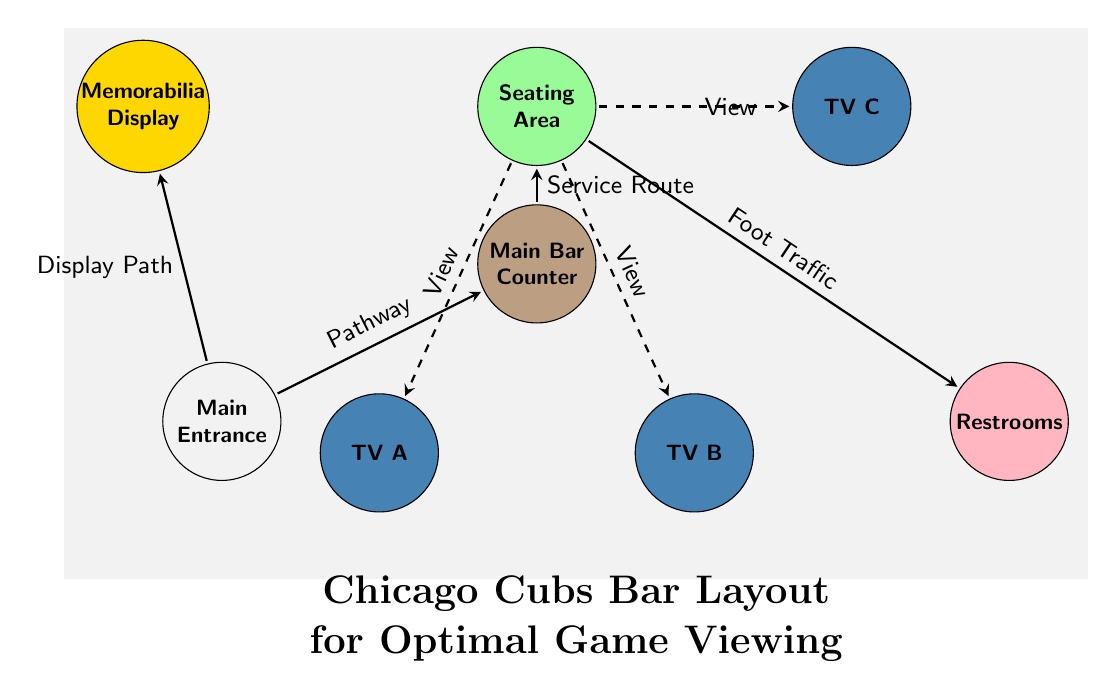What is the color of the main bar counter? The main bar counter is indicated in the diagram as a node filled with the color defined as "barcolor," which is RGB (188,158,130).
Answer: barcolor How many TVs are in the layout? The diagram shows three TVs labeled as TV A, TV B, and TV C. Counting these nodes reveals a total of three TVs.
Answer: 3 What is the purpose of the pathway from the entrance to the bar? The pathway connecting the entrance to the bar is labeled as "Pathway," indicating its purpose for customer entry and flow toward the bar.
Answer: Pathway What connects the seating area to the restrooms? The edge labeled "Foot Traffic" connects the seating area to the restrooms, suggesting that this is the route patrons would use to access the restrooms from seating.
Answer: Foot Traffic Which area is designated as a memorabilia display? The node labeled "Memorabilia Display" indicates the area where signed memorabilia is showcased within the bar layout, separate from other functional areas.
Answer: Memorabilia Display From which area is the service route leading to the seating area? The service route leads directly from the main bar counter to the seating area, indicating this path is used for bar service to patrons in the seating area.
Answer: Service Route Which TVs are visible from the seating area? The dashed lines indicate views from the seating area to TV A, TV B, and TV C, meaning all three TVs are viewable from this area.
Answer: TV A, TV B, TV C Is there a designated display path from the entrance to the memorabilia area? Yes, there is a direct connection labeled "Display Path" that suggests a route specifically for patrons to engage with the memorabilia upon entering the bar.
Answer: Display Path What is the layout's primary focus for customer experience? The layout prioritizes optimal game viewing, as indicated by the arrangement of seating areas relative to the TVs for the Cubs games.
Answer: Optimal Game Viewing 